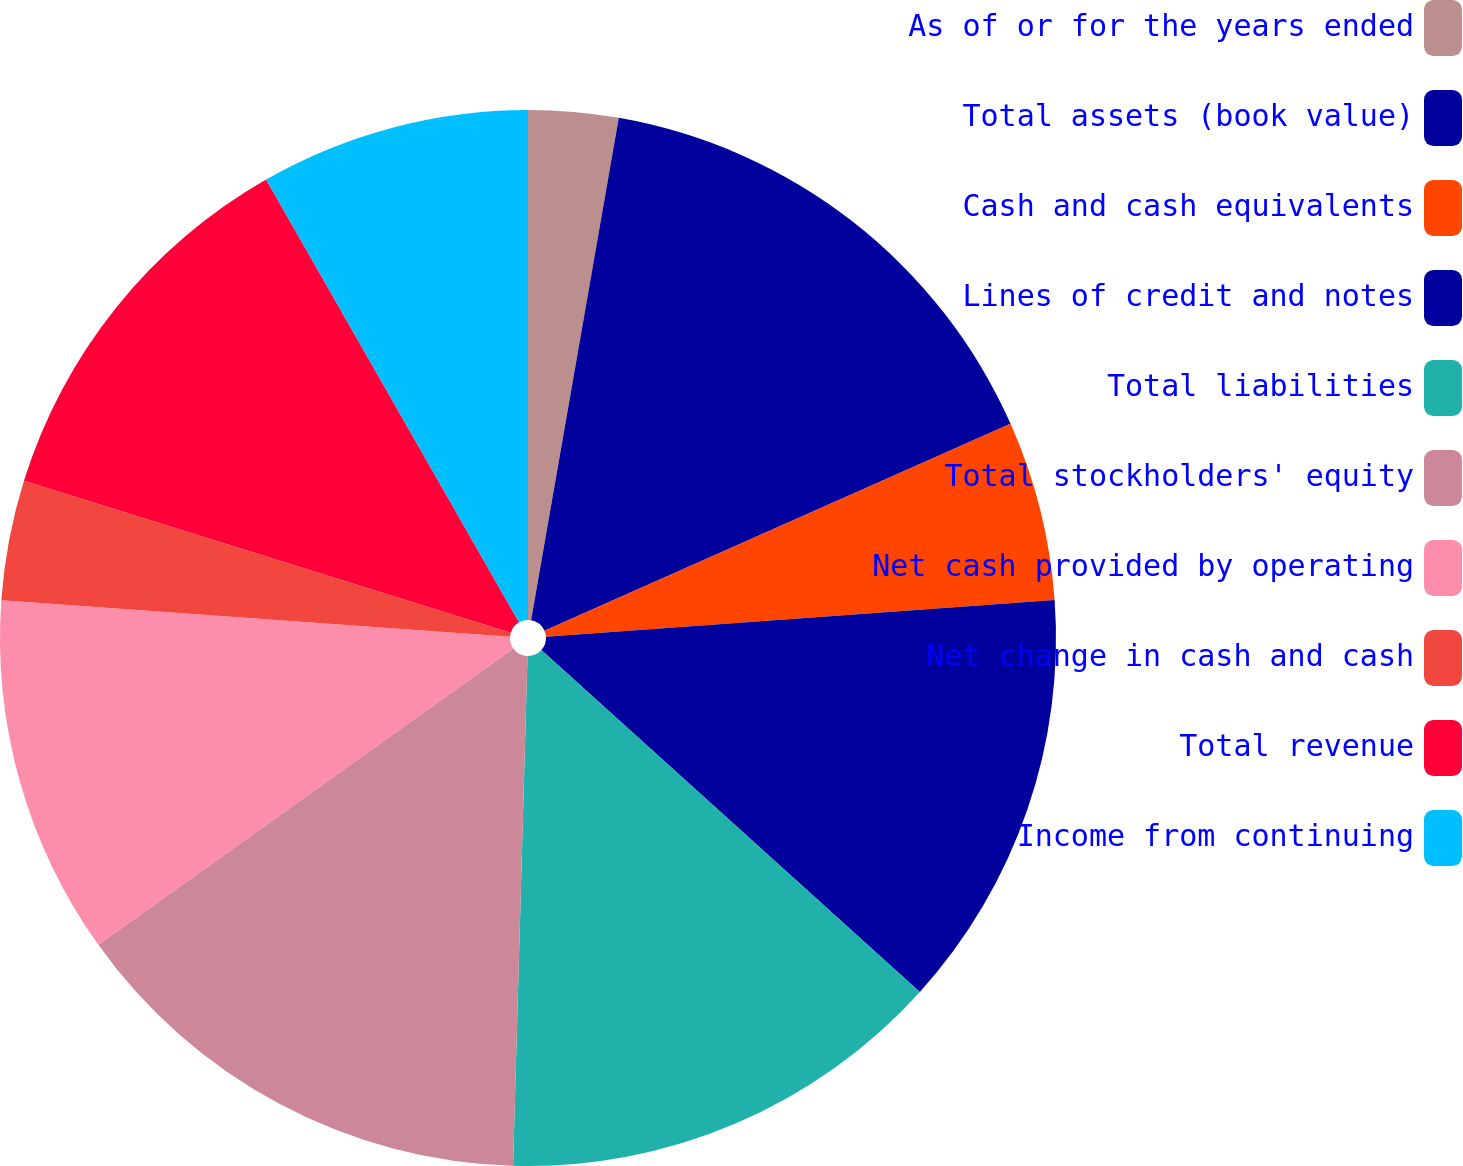Convert chart to OTSL. <chart><loc_0><loc_0><loc_500><loc_500><pie_chart><fcel>As of or for the years ended<fcel>Total assets (book value)<fcel>Cash and cash equivalents<fcel>Lines of credit and notes<fcel>Total liabilities<fcel>Total stockholders' equity<fcel>Net cash provided by operating<fcel>Net change in cash and cash<fcel>Total revenue<fcel>Income from continuing<nl><fcel>2.75%<fcel>15.6%<fcel>5.5%<fcel>12.84%<fcel>13.76%<fcel>14.68%<fcel>11.01%<fcel>3.67%<fcel>11.93%<fcel>8.26%<nl></chart> 